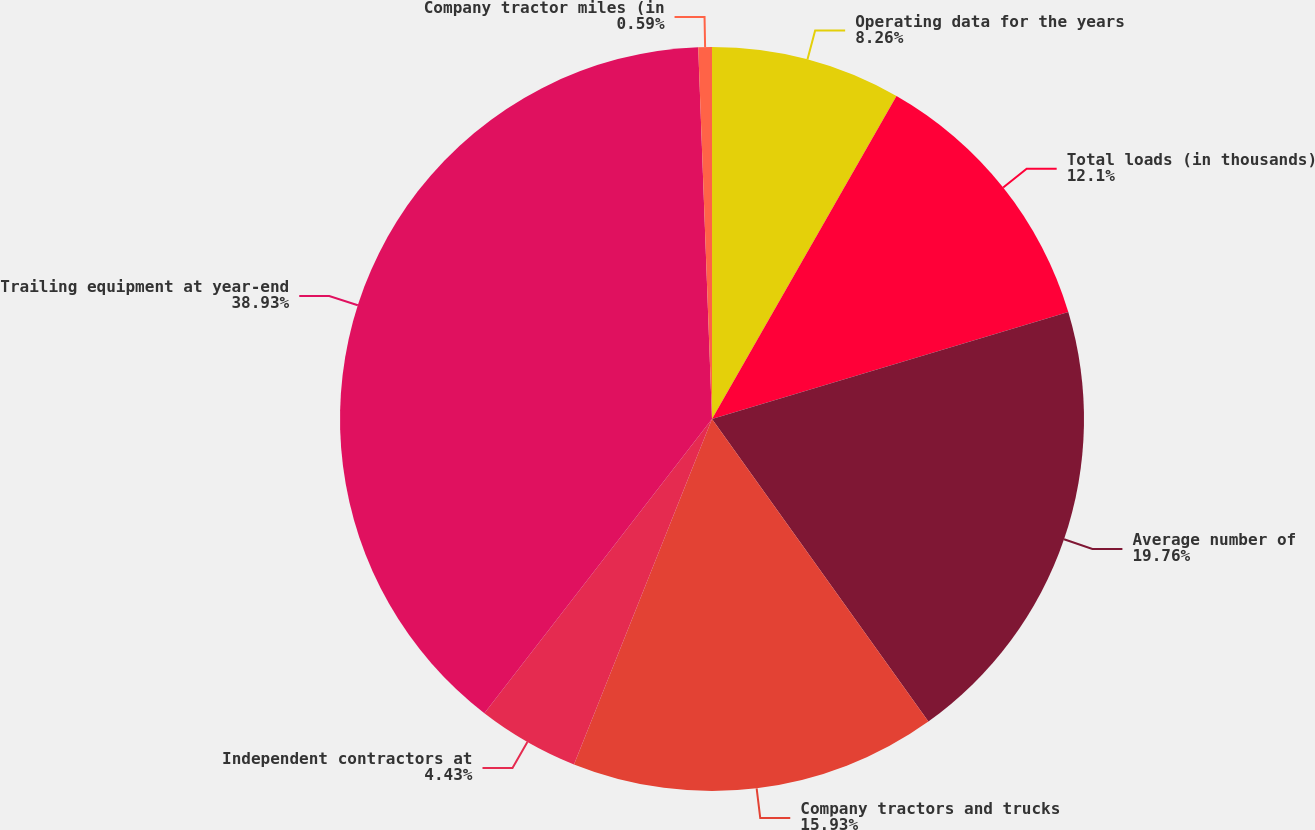Convert chart to OTSL. <chart><loc_0><loc_0><loc_500><loc_500><pie_chart><fcel>Operating data for the years<fcel>Total loads (in thousands)<fcel>Average number of<fcel>Company tractors and trucks<fcel>Independent contractors at<fcel>Trailing equipment at year-end<fcel>Company tractor miles (in<nl><fcel>8.26%<fcel>12.1%<fcel>19.76%<fcel>15.93%<fcel>4.43%<fcel>38.93%<fcel>0.59%<nl></chart> 